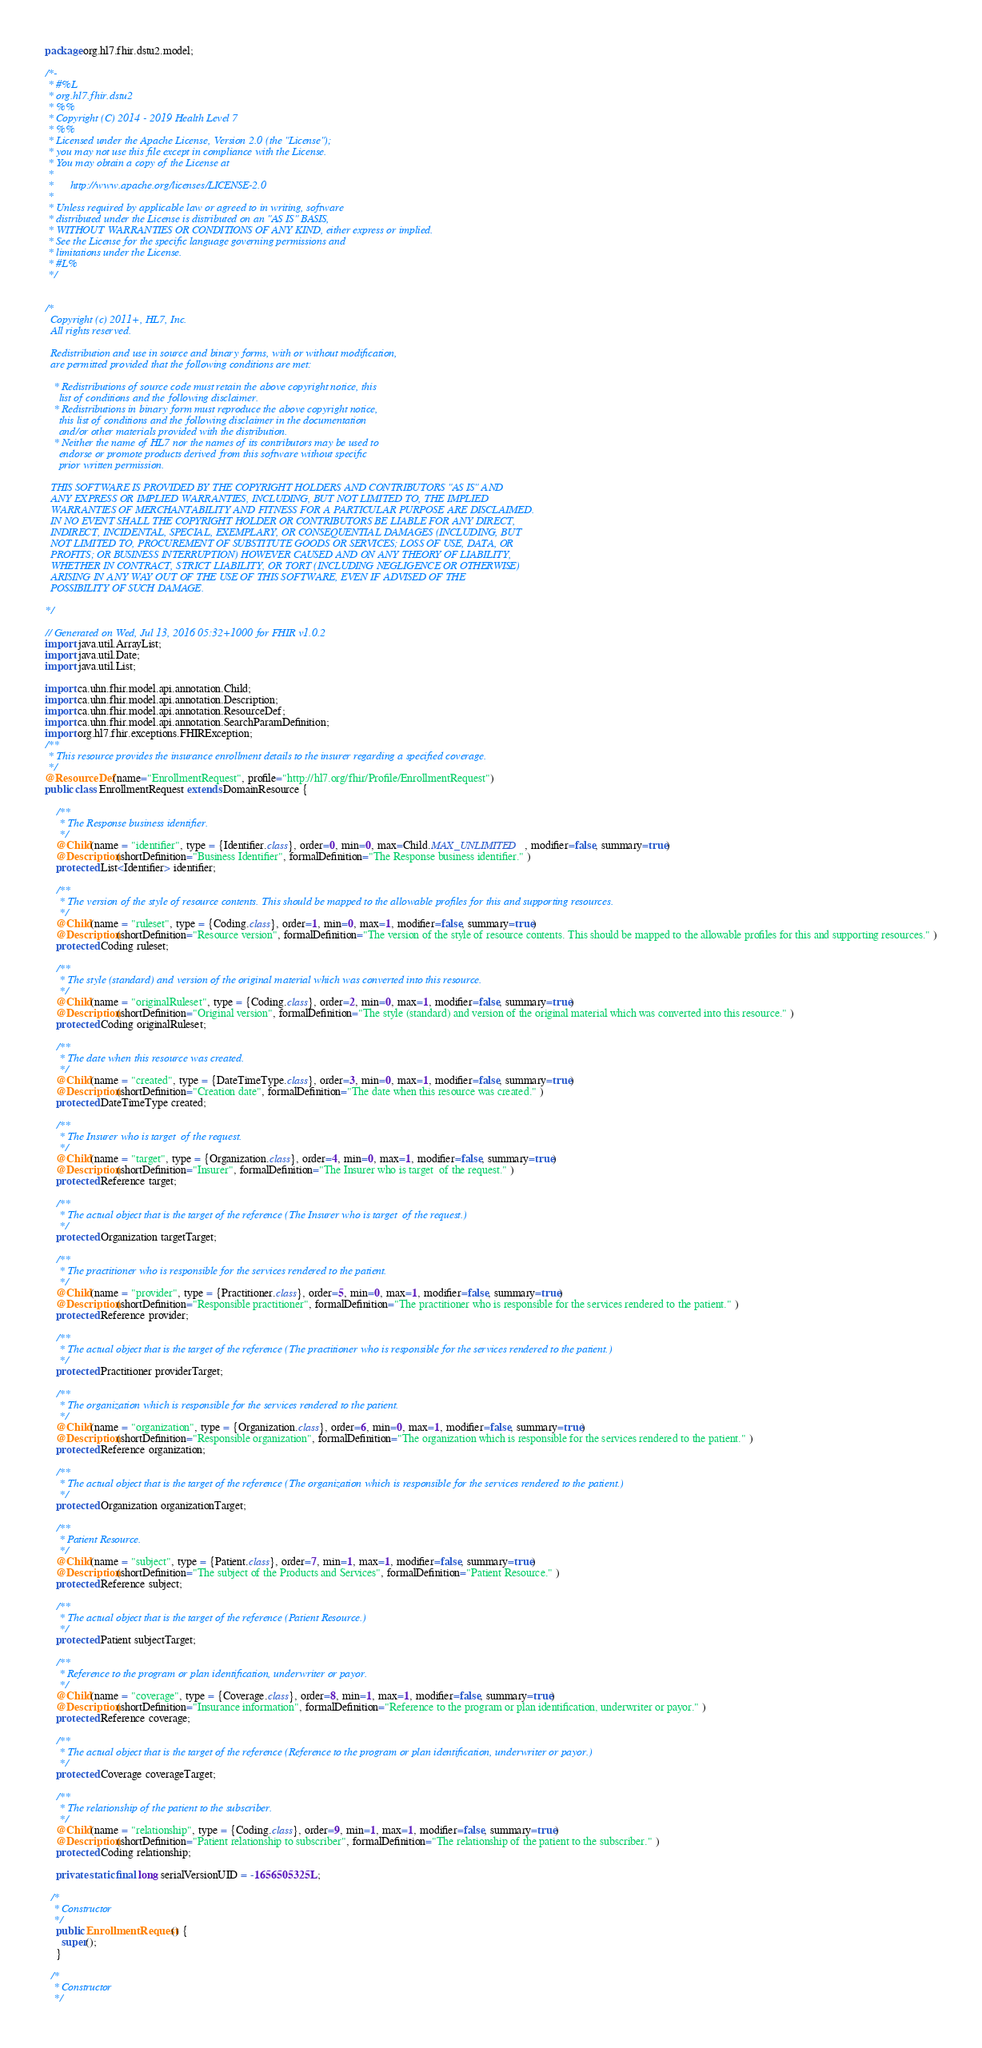<code> <loc_0><loc_0><loc_500><loc_500><_Java_>package org.hl7.fhir.dstu2.model;

/*-
 * #%L
 * org.hl7.fhir.dstu2
 * %%
 * Copyright (C) 2014 - 2019 Health Level 7
 * %%
 * Licensed under the Apache License, Version 2.0 (the "License");
 * you may not use this file except in compliance with the License.
 * You may obtain a copy of the License at
 * 
 *      http://www.apache.org/licenses/LICENSE-2.0
 * 
 * Unless required by applicable law or agreed to in writing, software
 * distributed under the License is distributed on an "AS IS" BASIS,
 * WITHOUT WARRANTIES OR CONDITIONS OF ANY KIND, either express or implied.
 * See the License for the specific language governing permissions and
 * limitations under the License.
 * #L%
 */


/*
  Copyright (c) 2011+, HL7, Inc.
  All rights reserved.
  
  Redistribution and use in source and binary forms, with or without modification, 
  are permitted provided that the following conditions are met:
  
   * Redistributions of source code must retain the above copyright notice, this 
     list of conditions and the following disclaimer.
   * Redistributions in binary form must reproduce the above copyright notice, 
     this list of conditions and the following disclaimer in the documentation 
     and/or other materials provided with the distribution.
   * Neither the name of HL7 nor the names of its contributors may be used to 
     endorse or promote products derived from this software without specific 
     prior written permission.
  
  THIS SOFTWARE IS PROVIDED BY THE COPYRIGHT HOLDERS AND CONTRIBUTORS "AS IS" AND 
  ANY EXPRESS OR IMPLIED WARRANTIES, INCLUDING, BUT NOT LIMITED TO, THE IMPLIED 
  WARRANTIES OF MERCHANTABILITY AND FITNESS FOR A PARTICULAR PURPOSE ARE DISCLAIMED. 
  IN NO EVENT SHALL THE COPYRIGHT HOLDER OR CONTRIBUTORS BE LIABLE FOR ANY DIRECT, 
  INDIRECT, INCIDENTAL, SPECIAL, EXEMPLARY, OR CONSEQUENTIAL DAMAGES (INCLUDING, BUT 
  NOT LIMITED TO, PROCUREMENT OF SUBSTITUTE GOODS OR SERVICES; LOSS OF USE, DATA, OR 
  PROFITS; OR BUSINESS INTERRUPTION) HOWEVER CAUSED AND ON ANY THEORY OF LIABILITY, 
  WHETHER IN CONTRACT, STRICT LIABILITY, OR TORT (INCLUDING NEGLIGENCE OR OTHERWISE) 
  ARISING IN ANY WAY OUT OF THE USE OF THIS SOFTWARE, EVEN IF ADVISED OF THE 
  POSSIBILITY OF SUCH DAMAGE.
  
*/

// Generated on Wed, Jul 13, 2016 05:32+1000 for FHIR v1.0.2
import java.util.ArrayList;
import java.util.Date;
import java.util.List;

import ca.uhn.fhir.model.api.annotation.Child;
import ca.uhn.fhir.model.api.annotation.Description;
import ca.uhn.fhir.model.api.annotation.ResourceDef;
import ca.uhn.fhir.model.api.annotation.SearchParamDefinition;
import org.hl7.fhir.exceptions.FHIRException;
/**
 * This resource provides the insurance enrollment details to the insurer regarding a specified coverage.
 */
@ResourceDef(name="EnrollmentRequest", profile="http://hl7.org/fhir/Profile/EnrollmentRequest")
public class EnrollmentRequest extends DomainResource {

    /**
     * The Response business identifier.
     */
    @Child(name = "identifier", type = {Identifier.class}, order=0, min=0, max=Child.MAX_UNLIMITED, modifier=false, summary=true)
    @Description(shortDefinition="Business Identifier", formalDefinition="The Response business identifier." )
    protected List<Identifier> identifier;

    /**
     * The version of the style of resource contents. This should be mapped to the allowable profiles for this and supporting resources.
     */
    @Child(name = "ruleset", type = {Coding.class}, order=1, min=0, max=1, modifier=false, summary=true)
    @Description(shortDefinition="Resource version", formalDefinition="The version of the style of resource contents. This should be mapped to the allowable profiles for this and supporting resources." )
    protected Coding ruleset;

    /**
     * The style (standard) and version of the original material which was converted into this resource.
     */
    @Child(name = "originalRuleset", type = {Coding.class}, order=2, min=0, max=1, modifier=false, summary=true)
    @Description(shortDefinition="Original version", formalDefinition="The style (standard) and version of the original material which was converted into this resource." )
    protected Coding originalRuleset;

    /**
     * The date when this resource was created.
     */
    @Child(name = "created", type = {DateTimeType.class}, order=3, min=0, max=1, modifier=false, summary=true)
    @Description(shortDefinition="Creation date", formalDefinition="The date when this resource was created." )
    protected DateTimeType created;

    /**
     * The Insurer who is target  of the request.
     */
    @Child(name = "target", type = {Organization.class}, order=4, min=0, max=1, modifier=false, summary=true)
    @Description(shortDefinition="Insurer", formalDefinition="The Insurer who is target  of the request." )
    protected Reference target;

    /**
     * The actual object that is the target of the reference (The Insurer who is target  of the request.)
     */
    protected Organization targetTarget;

    /**
     * The practitioner who is responsible for the services rendered to the patient.
     */
    @Child(name = "provider", type = {Practitioner.class}, order=5, min=0, max=1, modifier=false, summary=true)
    @Description(shortDefinition="Responsible practitioner", formalDefinition="The practitioner who is responsible for the services rendered to the patient." )
    protected Reference provider;

    /**
     * The actual object that is the target of the reference (The practitioner who is responsible for the services rendered to the patient.)
     */
    protected Practitioner providerTarget;

    /**
     * The organization which is responsible for the services rendered to the patient.
     */
    @Child(name = "organization", type = {Organization.class}, order=6, min=0, max=1, modifier=false, summary=true)
    @Description(shortDefinition="Responsible organization", formalDefinition="The organization which is responsible for the services rendered to the patient." )
    protected Reference organization;

    /**
     * The actual object that is the target of the reference (The organization which is responsible for the services rendered to the patient.)
     */
    protected Organization organizationTarget;

    /**
     * Patient Resource.
     */
    @Child(name = "subject", type = {Patient.class}, order=7, min=1, max=1, modifier=false, summary=true)
    @Description(shortDefinition="The subject of the Products and Services", formalDefinition="Patient Resource." )
    protected Reference subject;

    /**
     * The actual object that is the target of the reference (Patient Resource.)
     */
    protected Patient subjectTarget;

    /**
     * Reference to the program or plan identification, underwriter or payor.
     */
    @Child(name = "coverage", type = {Coverage.class}, order=8, min=1, max=1, modifier=false, summary=true)
    @Description(shortDefinition="Insurance information", formalDefinition="Reference to the program or plan identification, underwriter or payor." )
    protected Reference coverage;

    /**
     * The actual object that is the target of the reference (Reference to the program or plan identification, underwriter or payor.)
     */
    protected Coverage coverageTarget;

    /**
     * The relationship of the patient to the subscriber.
     */
    @Child(name = "relationship", type = {Coding.class}, order=9, min=1, max=1, modifier=false, summary=true)
    @Description(shortDefinition="Patient relationship to subscriber", formalDefinition="The relationship of the patient to the subscriber." )
    protected Coding relationship;

    private static final long serialVersionUID = -1656505325L;

  /*
   * Constructor
   */
    public EnrollmentRequest() {
      super();
    }

  /*
   * Constructor
   */</code> 